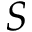Convert formula to latex. <formula><loc_0><loc_0><loc_500><loc_500>S</formula> 